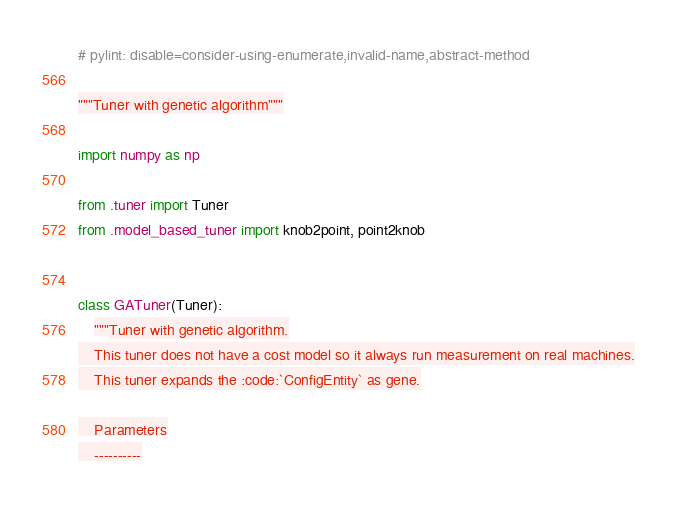<code> <loc_0><loc_0><loc_500><loc_500><_Python_># pylint: disable=consider-using-enumerate,invalid-name,abstract-method

"""Tuner with genetic algorithm"""

import numpy as np

from .tuner import Tuner
from .model_based_tuner import knob2point, point2knob


class GATuner(Tuner):
    """Tuner with genetic algorithm.
    This tuner does not have a cost model so it always run measurement on real machines.
    This tuner expands the :code:`ConfigEntity` as gene.

    Parameters
    ----------</code> 